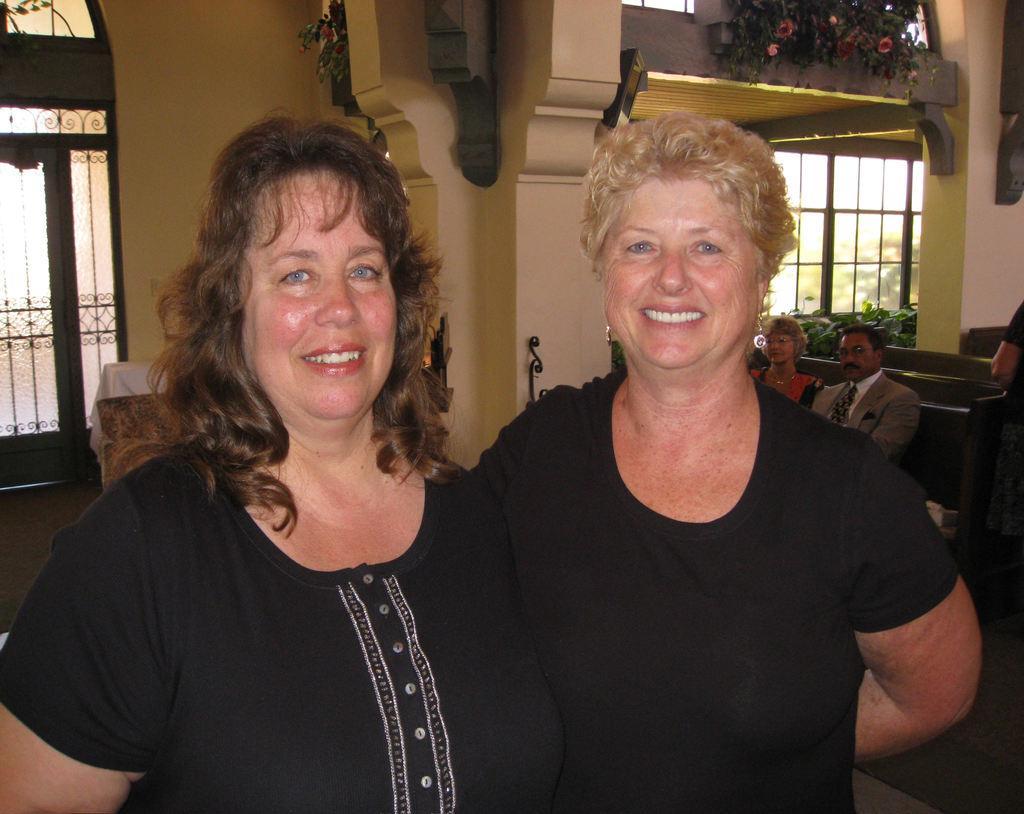Please provide a concise description of this image. In this image in the front there are women standing and smiling. In the center there are persons sitting and there is a person standing. In the background there are windows, flowers and there is a wall. 